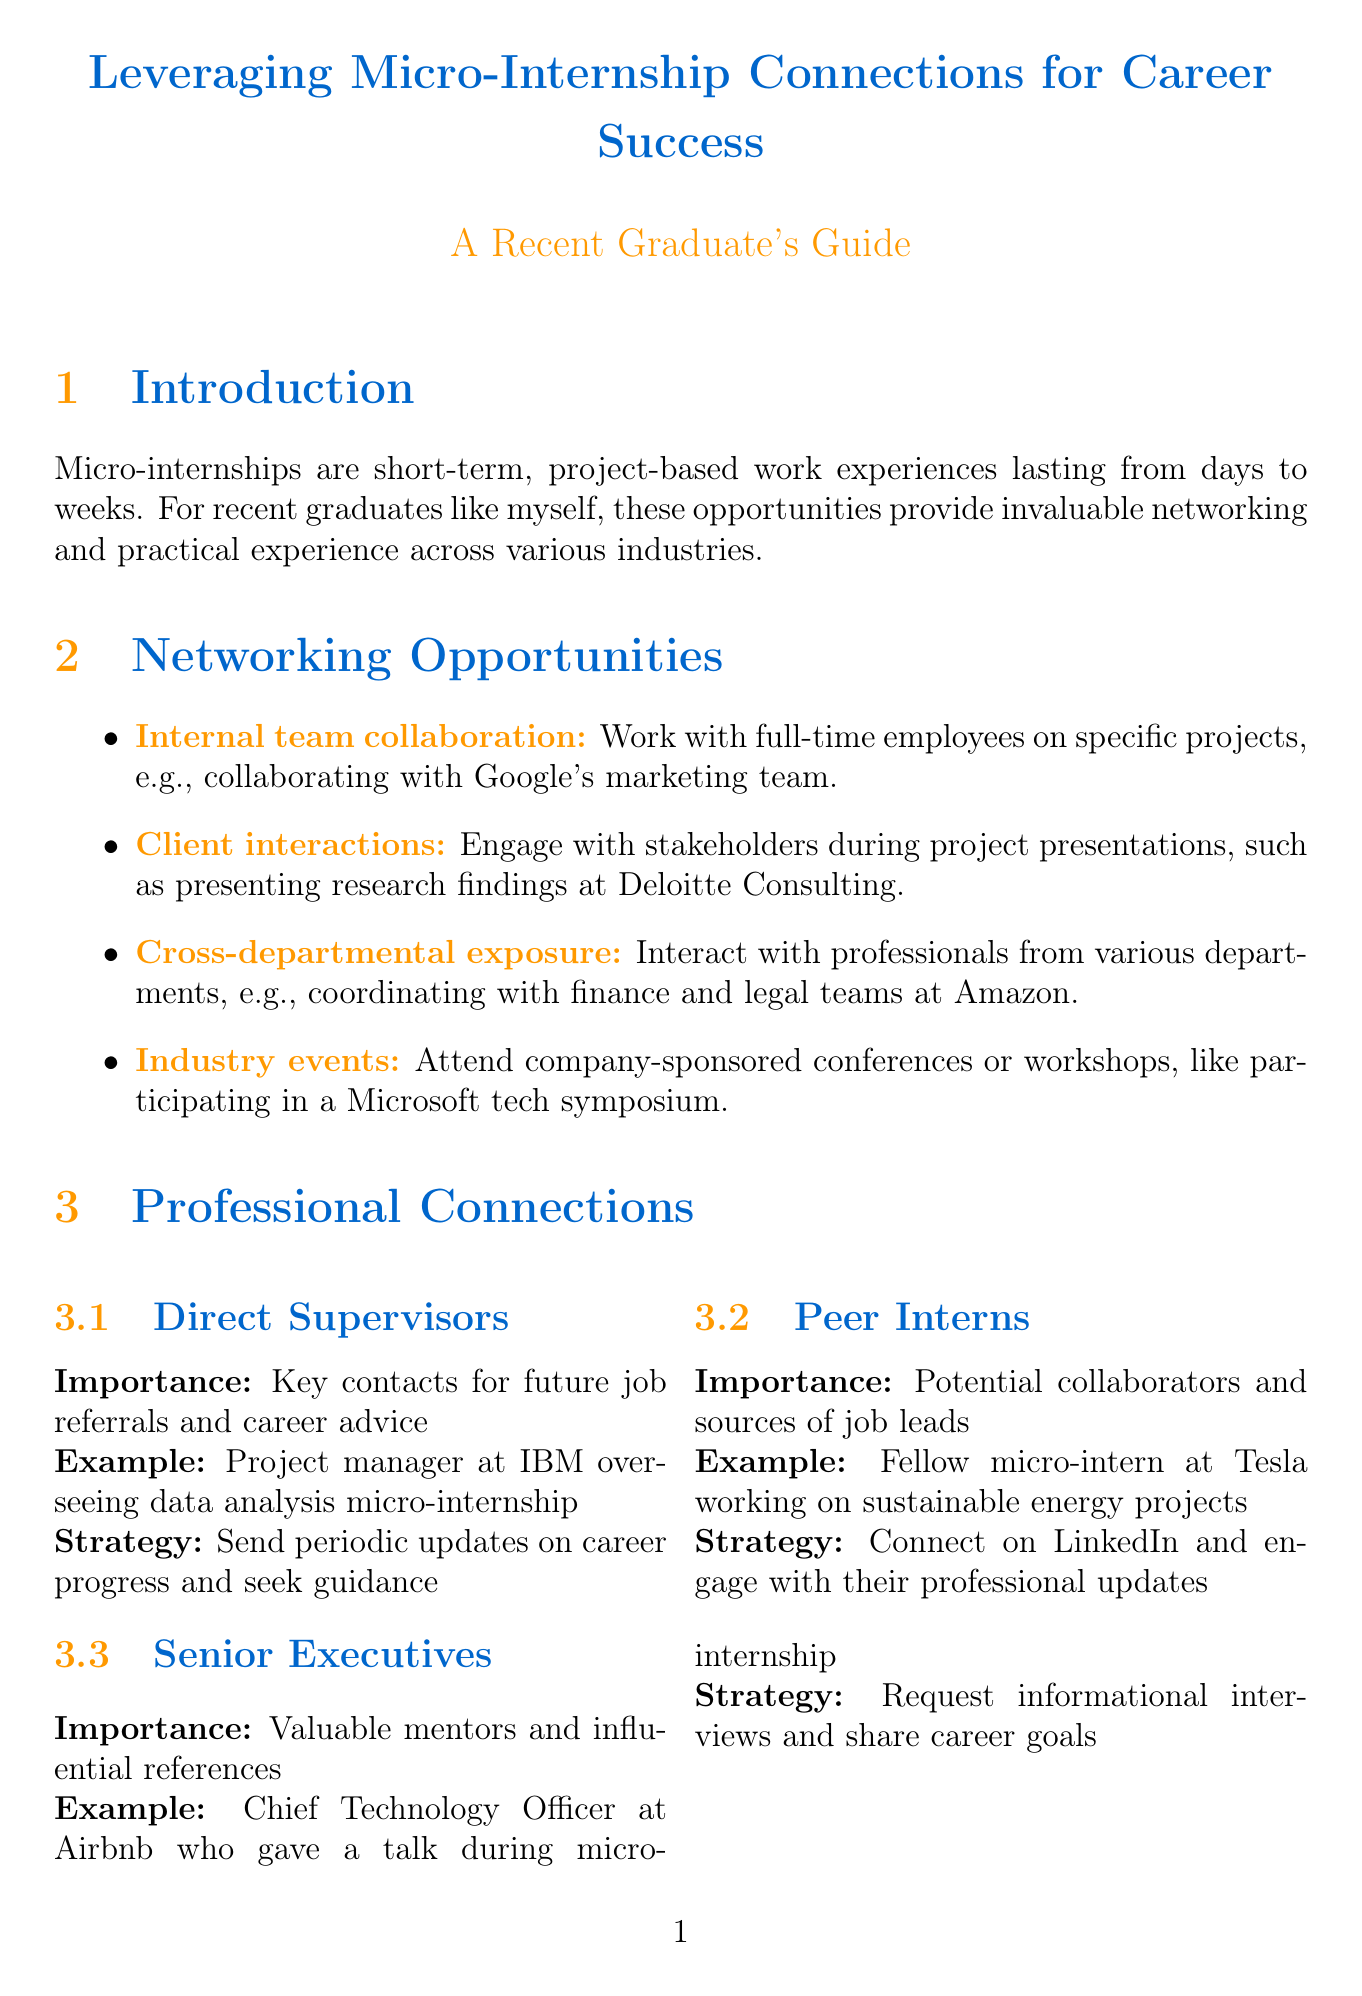What are micro-internships? Micro-internships are defined in the introduction as short-term, project-based work experiences that typically last from a few days to a few weeks.
Answer: Short-term, project-based work experiences What is one example of internal team collaboration? The document provides an example of collaborating with the marketing team at Google on a social media campaign under internal team collaboration.
Answer: Collaborating with the marketing team at Google Who is an example of a direct supervisor connection? The document lists a project manager at IBM who oversaw a data analysis micro-internship as an example of a direct supervisor connection.
Answer: Project manager at IBM What is one strategy for leveraging professional connections? The document lists "Create a micro-internship portfolio" as one of the strategies for leveraging professional connections.
Answer: Create a micro-internship portfolio What is a key takeaway from Sarah Chen's case study? The key takeaway stated in Sarah Chen's case study is about maintaining regular contact with supervisors potentially leading to job opportunities.
Answer: Maintaining regular contact with supervisors can lead to job opportunities Which social media platform is suggested for engaging with contacts? The document states that engaging with professional contacts on LinkedIn is recommended as part of the strategies for leveraging connections.
Answer: LinkedIn What is the main benefit of attending industry events? The document describes that attending industry events allows graduates to meet industry leaders and stay updated on the latest trends.
Answer: Meet industry leaders and stay updated on the latest trends What should be included in a micro-internship portfolio? The document suggests compiling a detailed record of projects, skills acquired, and key contacts from each micro-internship in a portfolio.
Answer: Projects, skills acquired, and key contacts What are the action items for networking mentioned in the conclusion? The document lists several action items including regularly updating your professional network on career progress and seeking mentorship.
Answer: Regularly update your professional network on career progress 